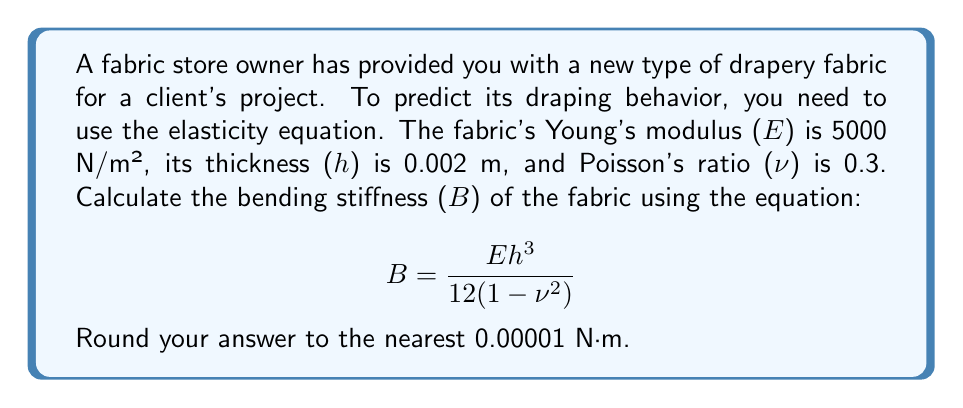Provide a solution to this math problem. To solve this problem, we'll use the given equation and substitute the known values:

$$ B = \frac{Eh^3}{12(1-\nu^2)} $$

Where:
E = Young's modulus = 5000 N/m²
h = Thickness = 0.002 m
ν = Poisson's ratio = 0.3

Let's substitute these values into the equation:

$$ B = \frac{5000 \cdot (0.002)^3}{12(1-0.3^2)} $$

Now, let's solve step by step:

1. Calculate $h^3$:
   $(0.002)^3 = 0.000000008$ m³

2. Calculate $1-\nu^2$:
   $1-0.3^2 = 1-0.09 = 0.91$

3. Multiply the numerator:
   $5000 \cdot 0.000000008 = 0.00004$ N·m³

4. Multiply the denominator:
   $12 \cdot 0.91 = 10.92$

5. Divide the numerator by the denominator:
   $\frac{0.00004}{10.92} \approx 0.00000366$ N·m

6. Round to the nearest 0.00001 N·m:
   0.00000 N·m
Answer: 0.00000 N·m 